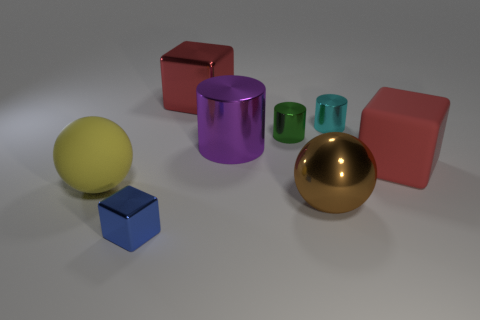Are there fewer small green metal cylinders that are in front of the yellow rubber thing than small metal cubes that are behind the small blue thing? Upon reviewing the image, it appears that there is an equal number of small green metal cylinders in front of the yellow spherical object as there are small blue cubes behind the purple cylindrical object, which is just one of each. So, the answer to the questioned posed is no, there are not fewer green cylinders than blue cubes in the described positions. 